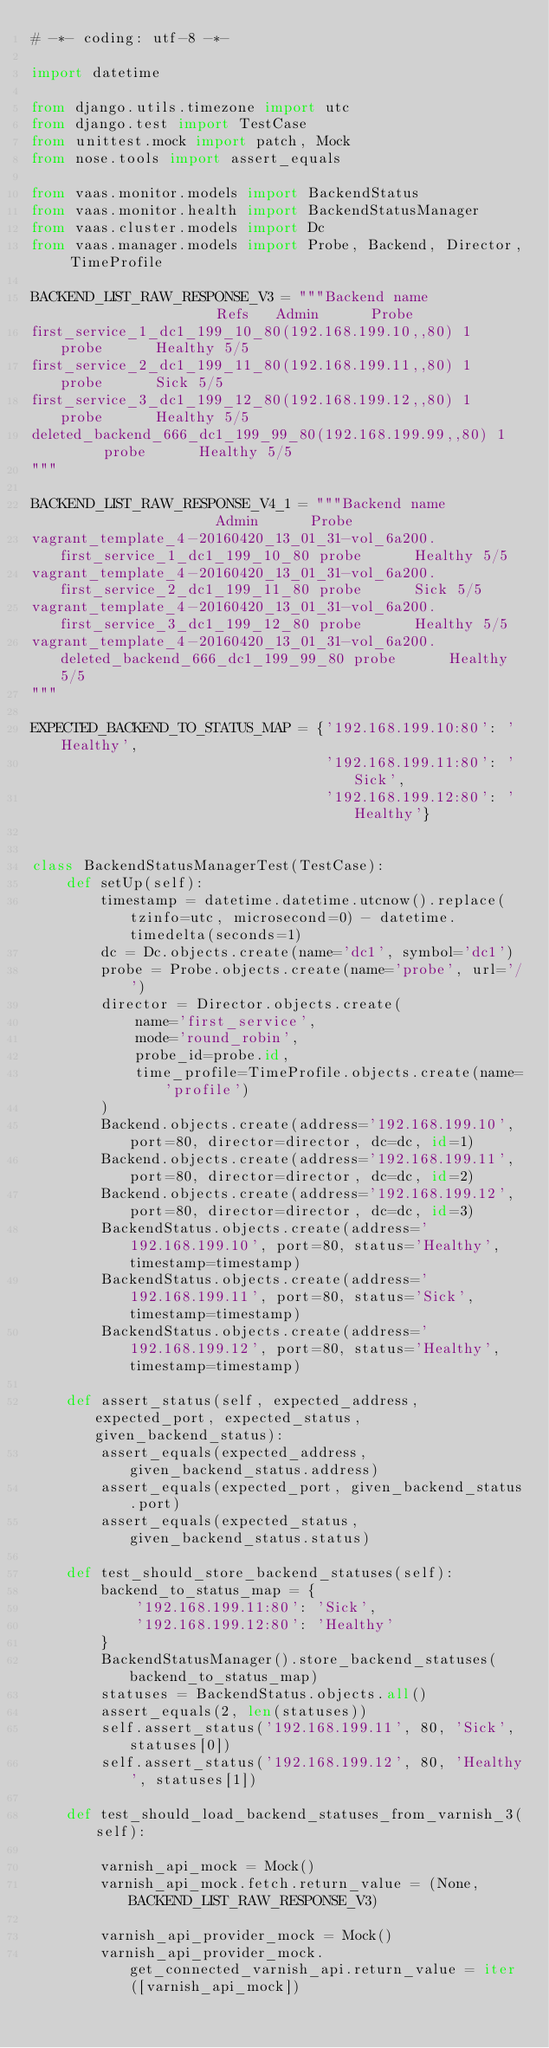Convert code to text. <code><loc_0><loc_0><loc_500><loc_500><_Python_># -*- coding: utf-8 -*-

import datetime

from django.utils.timezone import utc
from django.test import TestCase
from unittest.mock import patch, Mock
from nose.tools import assert_equals

from vaas.monitor.models import BackendStatus
from vaas.monitor.health import BackendStatusManager
from vaas.cluster.models import Dc
from vaas.manager.models import Probe, Backend, Director, TimeProfile

BACKEND_LIST_RAW_RESPONSE_V3 = """Backend name                   Refs   Admin      Probe
first_service_1_dc1_199_10_80(192.168.199.10,,80) 1      probe      Healthy 5/5
first_service_2_dc1_199_11_80(192.168.199.11,,80) 1      probe      Sick 5/5
first_service_3_dc1_199_12_80(192.168.199.12,,80) 1      probe      Healthy 5/5
deleted_backend_666_dc1_199_99_80(192.168.199.99,,80) 1      probe      Healthy 5/5
"""

BACKEND_LIST_RAW_RESPONSE_V4_1 = """Backend name                   Admin      Probe
vagrant_template_4-20160420_13_01_31-vol_6a200.first_service_1_dc1_199_10_80 probe      Healthy 5/5
vagrant_template_4-20160420_13_01_31-vol_6a200.first_service_2_dc1_199_11_80 probe      Sick 5/5
vagrant_template_4-20160420_13_01_31-vol_6a200.first_service_3_dc1_199_12_80 probe      Healthy 5/5
vagrant_template_4-20160420_13_01_31-vol_6a200.deleted_backend_666_dc1_199_99_80 probe      Healthy 5/5
"""

EXPECTED_BACKEND_TO_STATUS_MAP = {'192.168.199.10:80': 'Healthy',
                                  '192.168.199.11:80': 'Sick',
                                  '192.168.199.12:80': 'Healthy'}


class BackendStatusManagerTest(TestCase):
    def setUp(self):
        timestamp = datetime.datetime.utcnow().replace(tzinfo=utc, microsecond=0) - datetime.timedelta(seconds=1)
        dc = Dc.objects.create(name='dc1', symbol='dc1')
        probe = Probe.objects.create(name='probe', url='/')
        director = Director.objects.create(
            name='first_service',
            mode='round_robin',
            probe_id=probe.id,
            time_profile=TimeProfile.objects.create(name='profile')
        )
        Backend.objects.create(address='192.168.199.10', port=80, director=director, dc=dc, id=1)
        Backend.objects.create(address='192.168.199.11', port=80, director=director, dc=dc, id=2)
        Backend.objects.create(address='192.168.199.12', port=80, director=director, dc=dc, id=3)
        BackendStatus.objects.create(address='192.168.199.10', port=80, status='Healthy', timestamp=timestamp)
        BackendStatus.objects.create(address='192.168.199.11', port=80, status='Sick', timestamp=timestamp)
        BackendStatus.objects.create(address='192.168.199.12', port=80, status='Healthy', timestamp=timestamp)

    def assert_status(self, expected_address, expected_port, expected_status, given_backend_status):
        assert_equals(expected_address, given_backend_status.address)
        assert_equals(expected_port, given_backend_status.port)
        assert_equals(expected_status, given_backend_status.status)

    def test_should_store_backend_statuses(self):
        backend_to_status_map = {
            '192.168.199.11:80': 'Sick',
            '192.168.199.12:80': 'Healthy'
        }
        BackendStatusManager().store_backend_statuses(backend_to_status_map)
        statuses = BackendStatus.objects.all()
        assert_equals(2, len(statuses))
        self.assert_status('192.168.199.11', 80, 'Sick', statuses[0])
        self.assert_status('192.168.199.12', 80, 'Healthy', statuses[1])

    def test_should_load_backend_statuses_from_varnish_3(self):

        varnish_api_mock = Mock()
        varnish_api_mock.fetch.return_value = (None, BACKEND_LIST_RAW_RESPONSE_V3)

        varnish_api_provider_mock = Mock()
        varnish_api_provider_mock.get_connected_varnish_api.return_value = iter([varnish_api_mock])
</code> 